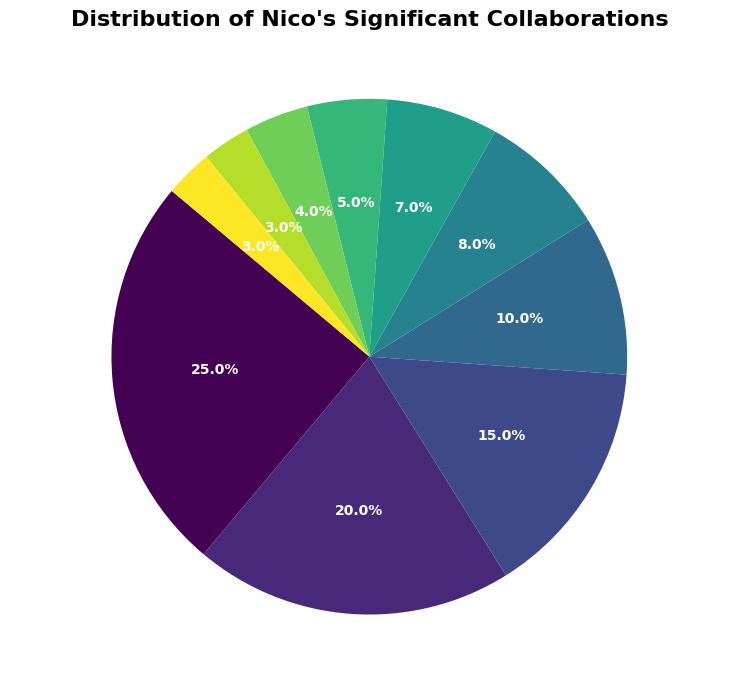What is the percentage of collaborations involving Lou Reed? Lou Reed's percentage is directly given in the chart.
Answer: 25% Which artist did Nico collaborate with more: Brian Eno or John Cale? Compare the percentages for Brian Eno (10%) and John Cale (20%). John Cale has a higher percentage.
Answer: John Cale What is the combined percentage of Nico's collaborations with Lou Reed and John Cale? Add the percentages for Lou Reed (25%) and John Cale (20%): 25% + 20% = 45%
Answer: 45% Among Jackson Browne, Brian Eno, and Philippe Garrel, who has the lowest percentage of collaborations with Nico? Compare the percentages: Jackson Browne (15%), Brian Eno (10%), and Philippe Garrel (8%). Philippe Garrel has the lowest percentage.
Answer: Philippe Garrel What is the total percentage of Nico's collaborations with artists associated with The Velvet Underground (Lou Reed, John Cale, The Velvet Underground)? Add the percentages for Lou Reed (25%), John Cale (20%), and The Velvet Underground (7%): 25% + 20% + 7% = 52%
Answer: 52% How many artists did Nico collaborate with for a percentage that is less than 10%? Identify the artists with percentages below 10%: Philippe Garrel (8%), The Velvet Underground (7%), Bob Dylan (5%), Iggy Pop (4%), Jim Morrison (3%), Marianne Faithfull (3%). There are 6 such artists.
Answer: 6 Which collaboration has the smallest visual section in the pie chart? The smallest percentage in the chart is with Jim Morrison and Marianne Faithfull, both at 3%.
Answer: Jim Morrison and Marianne Faithfull Which two artists have the same percentage of collaborations with Nico? Both Jim Morrison and Marianne Faithfull have 3% of collaborations.
Answer: Jim Morrison and Marianne Faithfull What is the difference in the percentage of collaborations between Lou Reed and The Velvet Underground? Subtract the percentage of The Velvet Underground (7%) from Lou Reed's (25%): 25% - 7% = 18%
Answer: 18% Is the percentage of Lou Reed's collaborations greater than the sum of Brian Eno and Bob Dylan's collaborations? Compare Lou Reed's 25% with the sum of Brian Eno (10%) and Bob Dylan (5%): 25% > 10% + 5% = 15%.
Answer: Yes 